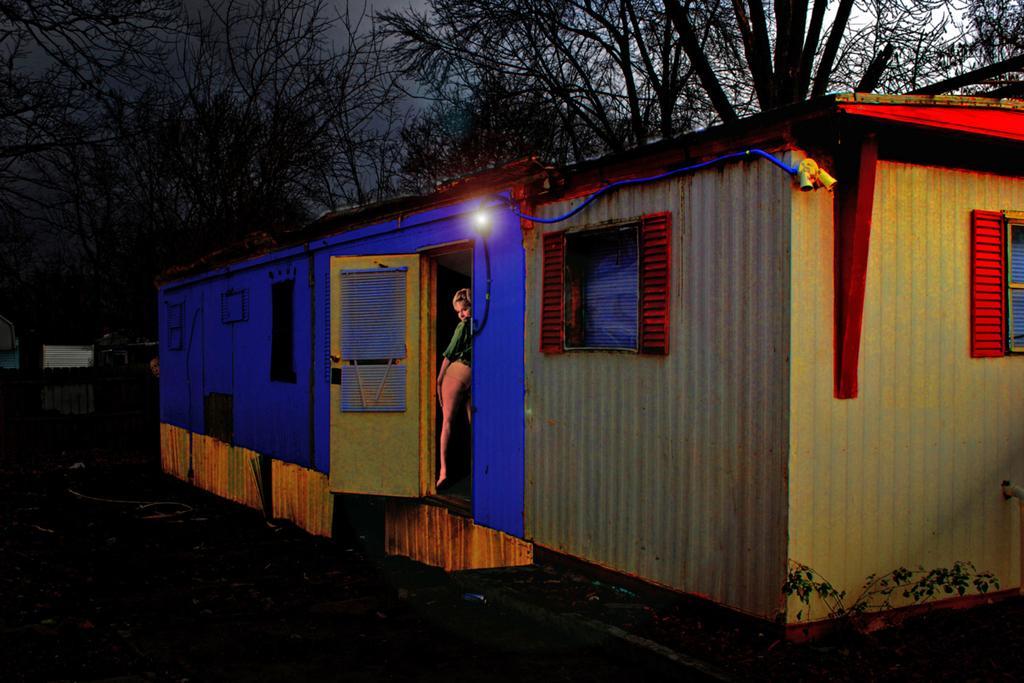Describe this image in one or two sentences. In this image I see the house and I see a woman over here and I see the light. In the background I see number of trees and I see that it is dark over here. 